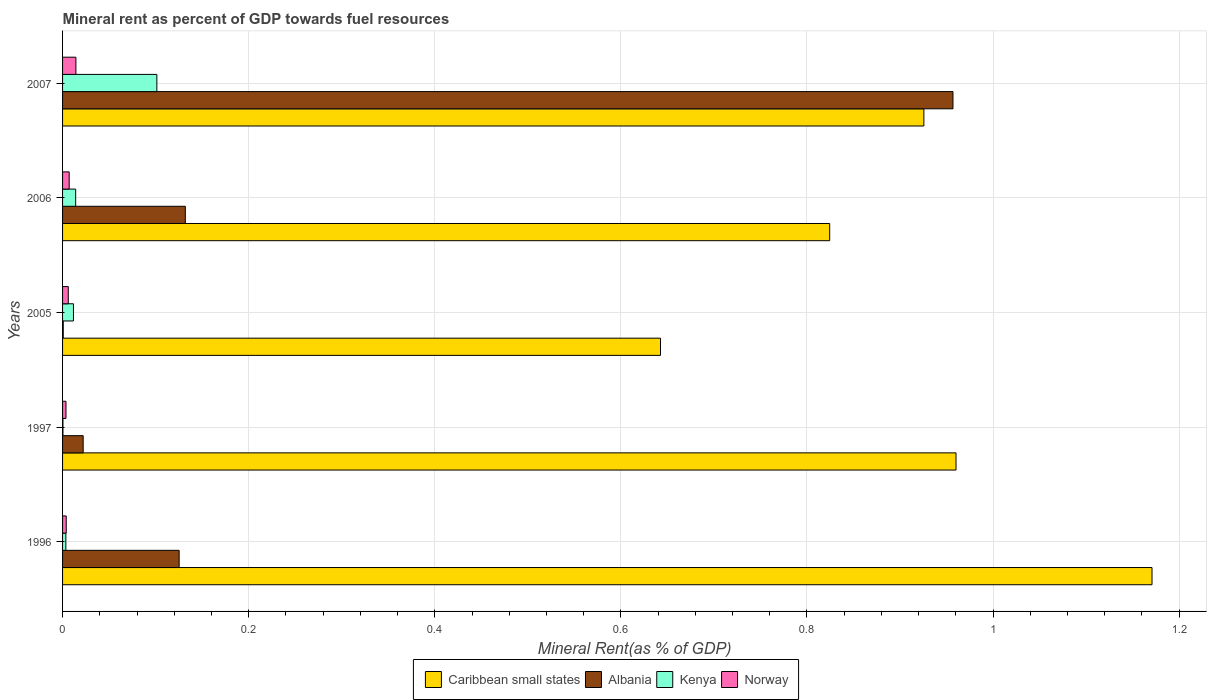How many different coloured bars are there?
Give a very brief answer. 4. How many groups of bars are there?
Offer a terse response. 5. Are the number of bars per tick equal to the number of legend labels?
Offer a very short reply. Yes. How many bars are there on the 2nd tick from the bottom?
Your response must be concise. 4. What is the label of the 1st group of bars from the top?
Give a very brief answer. 2007. What is the mineral rent in Kenya in 1997?
Your response must be concise. 0. Across all years, what is the maximum mineral rent in Albania?
Keep it short and to the point. 0.96. Across all years, what is the minimum mineral rent in Kenya?
Give a very brief answer. 0. In which year was the mineral rent in Albania minimum?
Provide a short and direct response. 2005. What is the total mineral rent in Albania in the graph?
Give a very brief answer. 1.24. What is the difference between the mineral rent in Caribbean small states in 1997 and that in 2007?
Provide a short and direct response. 0.03. What is the difference between the mineral rent in Norway in 1996 and the mineral rent in Kenya in 1997?
Make the answer very short. 0. What is the average mineral rent in Norway per year?
Offer a very short reply. 0.01. In the year 2006, what is the difference between the mineral rent in Albania and mineral rent in Kenya?
Provide a short and direct response. 0.12. In how many years, is the mineral rent in Norway greater than 0.16 %?
Provide a succinct answer. 0. What is the ratio of the mineral rent in Albania in 2006 to that in 2007?
Your answer should be compact. 0.14. Is the difference between the mineral rent in Albania in 2005 and 2006 greater than the difference between the mineral rent in Kenya in 2005 and 2006?
Your answer should be compact. No. What is the difference between the highest and the second highest mineral rent in Kenya?
Ensure brevity in your answer.  0.09. What is the difference between the highest and the lowest mineral rent in Kenya?
Give a very brief answer. 0.1. In how many years, is the mineral rent in Kenya greater than the average mineral rent in Kenya taken over all years?
Offer a very short reply. 1. What does the 2nd bar from the top in 2006 represents?
Your answer should be compact. Kenya. What does the 1st bar from the bottom in 2005 represents?
Give a very brief answer. Caribbean small states. Is it the case that in every year, the sum of the mineral rent in Norway and mineral rent in Caribbean small states is greater than the mineral rent in Kenya?
Your answer should be compact. Yes. Are all the bars in the graph horizontal?
Offer a terse response. Yes. How many years are there in the graph?
Offer a terse response. 5. What is the difference between two consecutive major ticks on the X-axis?
Your answer should be compact. 0.2. Are the values on the major ticks of X-axis written in scientific E-notation?
Offer a terse response. No. Does the graph contain grids?
Your response must be concise. Yes. Where does the legend appear in the graph?
Offer a very short reply. Bottom center. How many legend labels are there?
Provide a short and direct response. 4. How are the legend labels stacked?
Your answer should be very brief. Horizontal. What is the title of the graph?
Offer a very short reply. Mineral rent as percent of GDP towards fuel resources. Does "High income: nonOECD" appear as one of the legend labels in the graph?
Offer a very short reply. No. What is the label or title of the X-axis?
Your response must be concise. Mineral Rent(as % of GDP). What is the Mineral Rent(as % of GDP) in Caribbean small states in 1996?
Provide a short and direct response. 1.17. What is the Mineral Rent(as % of GDP) of Albania in 1996?
Your answer should be very brief. 0.13. What is the Mineral Rent(as % of GDP) in Kenya in 1996?
Your answer should be compact. 0. What is the Mineral Rent(as % of GDP) of Norway in 1996?
Provide a succinct answer. 0. What is the Mineral Rent(as % of GDP) of Caribbean small states in 1997?
Offer a very short reply. 0.96. What is the Mineral Rent(as % of GDP) in Albania in 1997?
Offer a very short reply. 0.02. What is the Mineral Rent(as % of GDP) in Kenya in 1997?
Ensure brevity in your answer.  0. What is the Mineral Rent(as % of GDP) of Norway in 1997?
Provide a short and direct response. 0. What is the Mineral Rent(as % of GDP) in Caribbean small states in 2005?
Offer a very short reply. 0.64. What is the Mineral Rent(as % of GDP) in Albania in 2005?
Your answer should be very brief. 0. What is the Mineral Rent(as % of GDP) of Kenya in 2005?
Provide a succinct answer. 0.01. What is the Mineral Rent(as % of GDP) of Norway in 2005?
Ensure brevity in your answer.  0.01. What is the Mineral Rent(as % of GDP) of Caribbean small states in 2006?
Keep it short and to the point. 0.82. What is the Mineral Rent(as % of GDP) in Albania in 2006?
Ensure brevity in your answer.  0.13. What is the Mineral Rent(as % of GDP) of Kenya in 2006?
Your response must be concise. 0.01. What is the Mineral Rent(as % of GDP) in Norway in 2006?
Give a very brief answer. 0.01. What is the Mineral Rent(as % of GDP) in Caribbean small states in 2007?
Your answer should be compact. 0.93. What is the Mineral Rent(as % of GDP) of Albania in 2007?
Provide a succinct answer. 0.96. What is the Mineral Rent(as % of GDP) of Kenya in 2007?
Keep it short and to the point. 0.1. What is the Mineral Rent(as % of GDP) of Norway in 2007?
Provide a short and direct response. 0.01. Across all years, what is the maximum Mineral Rent(as % of GDP) of Caribbean small states?
Your answer should be compact. 1.17. Across all years, what is the maximum Mineral Rent(as % of GDP) in Albania?
Keep it short and to the point. 0.96. Across all years, what is the maximum Mineral Rent(as % of GDP) of Kenya?
Offer a very short reply. 0.1. Across all years, what is the maximum Mineral Rent(as % of GDP) in Norway?
Provide a short and direct response. 0.01. Across all years, what is the minimum Mineral Rent(as % of GDP) in Caribbean small states?
Your answer should be compact. 0.64. Across all years, what is the minimum Mineral Rent(as % of GDP) in Albania?
Your answer should be very brief. 0. Across all years, what is the minimum Mineral Rent(as % of GDP) in Kenya?
Offer a terse response. 0. Across all years, what is the minimum Mineral Rent(as % of GDP) in Norway?
Your answer should be compact. 0. What is the total Mineral Rent(as % of GDP) in Caribbean small states in the graph?
Keep it short and to the point. 4.52. What is the total Mineral Rent(as % of GDP) in Albania in the graph?
Your response must be concise. 1.24. What is the total Mineral Rent(as % of GDP) in Kenya in the graph?
Give a very brief answer. 0.13. What is the total Mineral Rent(as % of GDP) of Norway in the graph?
Offer a very short reply. 0.04. What is the difference between the Mineral Rent(as % of GDP) of Caribbean small states in 1996 and that in 1997?
Keep it short and to the point. 0.21. What is the difference between the Mineral Rent(as % of GDP) in Albania in 1996 and that in 1997?
Make the answer very short. 0.1. What is the difference between the Mineral Rent(as % of GDP) in Kenya in 1996 and that in 1997?
Offer a very short reply. 0. What is the difference between the Mineral Rent(as % of GDP) in Norway in 1996 and that in 1997?
Provide a short and direct response. 0. What is the difference between the Mineral Rent(as % of GDP) of Caribbean small states in 1996 and that in 2005?
Offer a very short reply. 0.53. What is the difference between the Mineral Rent(as % of GDP) of Albania in 1996 and that in 2005?
Provide a succinct answer. 0.12. What is the difference between the Mineral Rent(as % of GDP) of Kenya in 1996 and that in 2005?
Your answer should be compact. -0.01. What is the difference between the Mineral Rent(as % of GDP) of Norway in 1996 and that in 2005?
Offer a terse response. -0. What is the difference between the Mineral Rent(as % of GDP) of Caribbean small states in 1996 and that in 2006?
Your answer should be very brief. 0.35. What is the difference between the Mineral Rent(as % of GDP) of Albania in 1996 and that in 2006?
Your answer should be compact. -0.01. What is the difference between the Mineral Rent(as % of GDP) of Kenya in 1996 and that in 2006?
Your response must be concise. -0.01. What is the difference between the Mineral Rent(as % of GDP) in Norway in 1996 and that in 2006?
Provide a short and direct response. -0. What is the difference between the Mineral Rent(as % of GDP) of Caribbean small states in 1996 and that in 2007?
Provide a short and direct response. 0.25. What is the difference between the Mineral Rent(as % of GDP) in Albania in 1996 and that in 2007?
Make the answer very short. -0.83. What is the difference between the Mineral Rent(as % of GDP) of Kenya in 1996 and that in 2007?
Offer a very short reply. -0.1. What is the difference between the Mineral Rent(as % of GDP) in Norway in 1996 and that in 2007?
Give a very brief answer. -0.01. What is the difference between the Mineral Rent(as % of GDP) of Caribbean small states in 1997 and that in 2005?
Offer a very short reply. 0.32. What is the difference between the Mineral Rent(as % of GDP) in Albania in 1997 and that in 2005?
Ensure brevity in your answer.  0.02. What is the difference between the Mineral Rent(as % of GDP) in Kenya in 1997 and that in 2005?
Offer a terse response. -0.01. What is the difference between the Mineral Rent(as % of GDP) in Norway in 1997 and that in 2005?
Offer a very short reply. -0. What is the difference between the Mineral Rent(as % of GDP) of Caribbean small states in 1997 and that in 2006?
Offer a terse response. 0.14. What is the difference between the Mineral Rent(as % of GDP) in Albania in 1997 and that in 2006?
Your answer should be very brief. -0.11. What is the difference between the Mineral Rent(as % of GDP) of Kenya in 1997 and that in 2006?
Offer a very short reply. -0.01. What is the difference between the Mineral Rent(as % of GDP) in Norway in 1997 and that in 2006?
Your answer should be very brief. -0. What is the difference between the Mineral Rent(as % of GDP) of Caribbean small states in 1997 and that in 2007?
Provide a short and direct response. 0.03. What is the difference between the Mineral Rent(as % of GDP) of Albania in 1997 and that in 2007?
Ensure brevity in your answer.  -0.93. What is the difference between the Mineral Rent(as % of GDP) of Kenya in 1997 and that in 2007?
Your answer should be very brief. -0.1. What is the difference between the Mineral Rent(as % of GDP) in Norway in 1997 and that in 2007?
Ensure brevity in your answer.  -0.01. What is the difference between the Mineral Rent(as % of GDP) of Caribbean small states in 2005 and that in 2006?
Provide a short and direct response. -0.18. What is the difference between the Mineral Rent(as % of GDP) of Albania in 2005 and that in 2006?
Make the answer very short. -0.13. What is the difference between the Mineral Rent(as % of GDP) in Kenya in 2005 and that in 2006?
Give a very brief answer. -0. What is the difference between the Mineral Rent(as % of GDP) in Norway in 2005 and that in 2006?
Your response must be concise. -0. What is the difference between the Mineral Rent(as % of GDP) in Caribbean small states in 2005 and that in 2007?
Make the answer very short. -0.28. What is the difference between the Mineral Rent(as % of GDP) of Albania in 2005 and that in 2007?
Make the answer very short. -0.96. What is the difference between the Mineral Rent(as % of GDP) in Kenya in 2005 and that in 2007?
Your answer should be compact. -0.09. What is the difference between the Mineral Rent(as % of GDP) in Norway in 2005 and that in 2007?
Keep it short and to the point. -0.01. What is the difference between the Mineral Rent(as % of GDP) in Caribbean small states in 2006 and that in 2007?
Your response must be concise. -0.1. What is the difference between the Mineral Rent(as % of GDP) in Albania in 2006 and that in 2007?
Make the answer very short. -0.82. What is the difference between the Mineral Rent(as % of GDP) in Kenya in 2006 and that in 2007?
Your response must be concise. -0.09. What is the difference between the Mineral Rent(as % of GDP) in Norway in 2006 and that in 2007?
Provide a short and direct response. -0.01. What is the difference between the Mineral Rent(as % of GDP) of Caribbean small states in 1996 and the Mineral Rent(as % of GDP) of Albania in 1997?
Your response must be concise. 1.15. What is the difference between the Mineral Rent(as % of GDP) of Caribbean small states in 1996 and the Mineral Rent(as % of GDP) of Kenya in 1997?
Your response must be concise. 1.17. What is the difference between the Mineral Rent(as % of GDP) of Caribbean small states in 1996 and the Mineral Rent(as % of GDP) of Norway in 1997?
Provide a succinct answer. 1.17. What is the difference between the Mineral Rent(as % of GDP) of Albania in 1996 and the Mineral Rent(as % of GDP) of Kenya in 1997?
Your answer should be compact. 0.12. What is the difference between the Mineral Rent(as % of GDP) in Albania in 1996 and the Mineral Rent(as % of GDP) in Norway in 1997?
Ensure brevity in your answer.  0.12. What is the difference between the Mineral Rent(as % of GDP) in Kenya in 1996 and the Mineral Rent(as % of GDP) in Norway in 1997?
Your answer should be compact. -0. What is the difference between the Mineral Rent(as % of GDP) of Caribbean small states in 1996 and the Mineral Rent(as % of GDP) of Albania in 2005?
Your answer should be compact. 1.17. What is the difference between the Mineral Rent(as % of GDP) in Caribbean small states in 1996 and the Mineral Rent(as % of GDP) in Kenya in 2005?
Your answer should be compact. 1.16. What is the difference between the Mineral Rent(as % of GDP) of Caribbean small states in 1996 and the Mineral Rent(as % of GDP) of Norway in 2005?
Provide a short and direct response. 1.16. What is the difference between the Mineral Rent(as % of GDP) of Albania in 1996 and the Mineral Rent(as % of GDP) of Kenya in 2005?
Your answer should be very brief. 0.11. What is the difference between the Mineral Rent(as % of GDP) of Albania in 1996 and the Mineral Rent(as % of GDP) of Norway in 2005?
Keep it short and to the point. 0.12. What is the difference between the Mineral Rent(as % of GDP) of Kenya in 1996 and the Mineral Rent(as % of GDP) of Norway in 2005?
Your answer should be very brief. -0. What is the difference between the Mineral Rent(as % of GDP) of Caribbean small states in 1996 and the Mineral Rent(as % of GDP) of Albania in 2006?
Make the answer very short. 1.04. What is the difference between the Mineral Rent(as % of GDP) in Caribbean small states in 1996 and the Mineral Rent(as % of GDP) in Kenya in 2006?
Offer a terse response. 1.16. What is the difference between the Mineral Rent(as % of GDP) in Caribbean small states in 1996 and the Mineral Rent(as % of GDP) in Norway in 2006?
Provide a succinct answer. 1.16. What is the difference between the Mineral Rent(as % of GDP) in Albania in 1996 and the Mineral Rent(as % of GDP) in Kenya in 2006?
Provide a succinct answer. 0.11. What is the difference between the Mineral Rent(as % of GDP) in Albania in 1996 and the Mineral Rent(as % of GDP) in Norway in 2006?
Provide a succinct answer. 0.12. What is the difference between the Mineral Rent(as % of GDP) of Kenya in 1996 and the Mineral Rent(as % of GDP) of Norway in 2006?
Provide a short and direct response. -0. What is the difference between the Mineral Rent(as % of GDP) of Caribbean small states in 1996 and the Mineral Rent(as % of GDP) of Albania in 2007?
Provide a succinct answer. 0.21. What is the difference between the Mineral Rent(as % of GDP) in Caribbean small states in 1996 and the Mineral Rent(as % of GDP) in Kenya in 2007?
Offer a very short reply. 1.07. What is the difference between the Mineral Rent(as % of GDP) of Caribbean small states in 1996 and the Mineral Rent(as % of GDP) of Norway in 2007?
Your answer should be very brief. 1.16. What is the difference between the Mineral Rent(as % of GDP) in Albania in 1996 and the Mineral Rent(as % of GDP) in Kenya in 2007?
Keep it short and to the point. 0.02. What is the difference between the Mineral Rent(as % of GDP) in Albania in 1996 and the Mineral Rent(as % of GDP) in Norway in 2007?
Provide a short and direct response. 0.11. What is the difference between the Mineral Rent(as % of GDP) in Kenya in 1996 and the Mineral Rent(as % of GDP) in Norway in 2007?
Make the answer very short. -0.01. What is the difference between the Mineral Rent(as % of GDP) of Caribbean small states in 1997 and the Mineral Rent(as % of GDP) of Albania in 2005?
Your answer should be very brief. 0.96. What is the difference between the Mineral Rent(as % of GDP) in Caribbean small states in 1997 and the Mineral Rent(as % of GDP) in Kenya in 2005?
Your response must be concise. 0.95. What is the difference between the Mineral Rent(as % of GDP) in Caribbean small states in 1997 and the Mineral Rent(as % of GDP) in Norway in 2005?
Provide a succinct answer. 0.95. What is the difference between the Mineral Rent(as % of GDP) in Albania in 1997 and the Mineral Rent(as % of GDP) in Kenya in 2005?
Your answer should be compact. 0.01. What is the difference between the Mineral Rent(as % of GDP) of Albania in 1997 and the Mineral Rent(as % of GDP) of Norway in 2005?
Ensure brevity in your answer.  0.02. What is the difference between the Mineral Rent(as % of GDP) in Kenya in 1997 and the Mineral Rent(as % of GDP) in Norway in 2005?
Keep it short and to the point. -0.01. What is the difference between the Mineral Rent(as % of GDP) of Caribbean small states in 1997 and the Mineral Rent(as % of GDP) of Albania in 2006?
Offer a very short reply. 0.83. What is the difference between the Mineral Rent(as % of GDP) in Caribbean small states in 1997 and the Mineral Rent(as % of GDP) in Kenya in 2006?
Your response must be concise. 0.95. What is the difference between the Mineral Rent(as % of GDP) in Caribbean small states in 1997 and the Mineral Rent(as % of GDP) in Norway in 2006?
Your answer should be very brief. 0.95. What is the difference between the Mineral Rent(as % of GDP) of Albania in 1997 and the Mineral Rent(as % of GDP) of Kenya in 2006?
Offer a very short reply. 0.01. What is the difference between the Mineral Rent(as % of GDP) in Albania in 1997 and the Mineral Rent(as % of GDP) in Norway in 2006?
Give a very brief answer. 0.01. What is the difference between the Mineral Rent(as % of GDP) in Kenya in 1997 and the Mineral Rent(as % of GDP) in Norway in 2006?
Provide a short and direct response. -0.01. What is the difference between the Mineral Rent(as % of GDP) of Caribbean small states in 1997 and the Mineral Rent(as % of GDP) of Albania in 2007?
Your answer should be very brief. 0. What is the difference between the Mineral Rent(as % of GDP) of Caribbean small states in 1997 and the Mineral Rent(as % of GDP) of Kenya in 2007?
Provide a succinct answer. 0.86. What is the difference between the Mineral Rent(as % of GDP) of Caribbean small states in 1997 and the Mineral Rent(as % of GDP) of Norway in 2007?
Your response must be concise. 0.95. What is the difference between the Mineral Rent(as % of GDP) in Albania in 1997 and the Mineral Rent(as % of GDP) in Kenya in 2007?
Offer a terse response. -0.08. What is the difference between the Mineral Rent(as % of GDP) in Albania in 1997 and the Mineral Rent(as % of GDP) in Norway in 2007?
Your answer should be compact. 0.01. What is the difference between the Mineral Rent(as % of GDP) of Kenya in 1997 and the Mineral Rent(as % of GDP) of Norway in 2007?
Your response must be concise. -0.01. What is the difference between the Mineral Rent(as % of GDP) in Caribbean small states in 2005 and the Mineral Rent(as % of GDP) in Albania in 2006?
Ensure brevity in your answer.  0.51. What is the difference between the Mineral Rent(as % of GDP) in Caribbean small states in 2005 and the Mineral Rent(as % of GDP) in Kenya in 2006?
Provide a short and direct response. 0.63. What is the difference between the Mineral Rent(as % of GDP) in Caribbean small states in 2005 and the Mineral Rent(as % of GDP) in Norway in 2006?
Keep it short and to the point. 0.64. What is the difference between the Mineral Rent(as % of GDP) in Albania in 2005 and the Mineral Rent(as % of GDP) in Kenya in 2006?
Keep it short and to the point. -0.01. What is the difference between the Mineral Rent(as % of GDP) of Albania in 2005 and the Mineral Rent(as % of GDP) of Norway in 2006?
Your answer should be very brief. -0.01. What is the difference between the Mineral Rent(as % of GDP) of Kenya in 2005 and the Mineral Rent(as % of GDP) of Norway in 2006?
Make the answer very short. 0. What is the difference between the Mineral Rent(as % of GDP) in Caribbean small states in 2005 and the Mineral Rent(as % of GDP) in Albania in 2007?
Your answer should be very brief. -0.31. What is the difference between the Mineral Rent(as % of GDP) of Caribbean small states in 2005 and the Mineral Rent(as % of GDP) of Kenya in 2007?
Keep it short and to the point. 0.54. What is the difference between the Mineral Rent(as % of GDP) of Caribbean small states in 2005 and the Mineral Rent(as % of GDP) of Norway in 2007?
Your answer should be compact. 0.63. What is the difference between the Mineral Rent(as % of GDP) in Albania in 2005 and the Mineral Rent(as % of GDP) in Kenya in 2007?
Your answer should be very brief. -0.1. What is the difference between the Mineral Rent(as % of GDP) in Albania in 2005 and the Mineral Rent(as % of GDP) in Norway in 2007?
Offer a very short reply. -0.01. What is the difference between the Mineral Rent(as % of GDP) in Kenya in 2005 and the Mineral Rent(as % of GDP) in Norway in 2007?
Give a very brief answer. -0. What is the difference between the Mineral Rent(as % of GDP) of Caribbean small states in 2006 and the Mineral Rent(as % of GDP) of Albania in 2007?
Offer a very short reply. -0.13. What is the difference between the Mineral Rent(as % of GDP) in Caribbean small states in 2006 and the Mineral Rent(as % of GDP) in Kenya in 2007?
Provide a short and direct response. 0.72. What is the difference between the Mineral Rent(as % of GDP) of Caribbean small states in 2006 and the Mineral Rent(as % of GDP) of Norway in 2007?
Your answer should be very brief. 0.81. What is the difference between the Mineral Rent(as % of GDP) in Albania in 2006 and the Mineral Rent(as % of GDP) in Kenya in 2007?
Your answer should be compact. 0.03. What is the difference between the Mineral Rent(as % of GDP) in Albania in 2006 and the Mineral Rent(as % of GDP) in Norway in 2007?
Give a very brief answer. 0.12. What is the difference between the Mineral Rent(as % of GDP) in Kenya in 2006 and the Mineral Rent(as % of GDP) in Norway in 2007?
Your response must be concise. -0. What is the average Mineral Rent(as % of GDP) in Caribbean small states per year?
Make the answer very short. 0.9. What is the average Mineral Rent(as % of GDP) of Albania per year?
Keep it short and to the point. 0.25. What is the average Mineral Rent(as % of GDP) of Kenya per year?
Give a very brief answer. 0.03. What is the average Mineral Rent(as % of GDP) of Norway per year?
Give a very brief answer. 0.01. In the year 1996, what is the difference between the Mineral Rent(as % of GDP) of Caribbean small states and Mineral Rent(as % of GDP) of Albania?
Provide a short and direct response. 1.05. In the year 1996, what is the difference between the Mineral Rent(as % of GDP) of Caribbean small states and Mineral Rent(as % of GDP) of Kenya?
Your response must be concise. 1.17. In the year 1996, what is the difference between the Mineral Rent(as % of GDP) in Caribbean small states and Mineral Rent(as % of GDP) in Norway?
Offer a very short reply. 1.17. In the year 1996, what is the difference between the Mineral Rent(as % of GDP) of Albania and Mineral Rent(as % of GDP) of Kenya?
Give a very brief answer. 0.12. In the year 1996, what is the difference between the Mineral Rent(as % of GDP) of Albania and Mineral Rent(as % of GDP) of Norway?
Make the answer very short. 0.12. In the year 1996, what is the difference between the Mineral Rent(as % of GDP) in Kenya and Mineral Rent(as % of GDP) in Norway?
Provide a short and direct response. -0. In the year 1997, what is the difference between the Mineral Rent(as % of GDP) of Caribbean small states and Mineral Rent(as % of GDP) of Albania?
Provide a short and direct response. 0.94. In the year 1997, what is the difference between the Mineral Rent(as % of GDP) of Caribbean small states and Mineral Rent(as % of GDP) of Kenya?
Your answer should be very brief. 0.96. In the year 1997, what is the difference between the Mineral Rent(as % of GDP) of Caribbean small states and Mineral Rent(as % of GDP) of Norway?
Keep it short and to the point. 0.96. In the year 1997, what is the difference between the Mineral Rent(as % of GDP) in Albania and Mineral Rent(as % of GDP) in Kenya?
Ensure brevity in your answer.  0.02. In the year 1997, what is the difference between the Mineral Rent(as % of GDP) in Albania and Mineral Rent(as % of GDP) in Norway?
Provide a succinct answer. 0.02. In the year 1997, what is the difference between the Mineral Rent(as % of GDP) in Kenya and Mineral Rent(as % of GDP) in Norway?
Your answer should be compact. -0. In the year 2005, what is the difference between the Mineral Rent(as % of GDP) of Caribbean small states and Mineral Rent(as % of GDP) of Albania?
Your response must be concise. 0.64. In the year 2005, what is the difference between the Mineral Rent(as % of GDP) in Caribbean small states and Mineral Rent(as % of GDP) in Kenya?
Provide a short and direct response. 0.63. In the year 2005, what is the difference between the Mineral Rent(as % of GDP) in Caribbean small states and Mineral Rent(as % of GDP) in Norway?
Offer a terse response. 0.64. In the year 2005, what is the difference between the Mineral Rent(as % of GDP) in Albania and Mineral Rent(as % of GDP) in Kenya?
Give a very brief answer. -0.01. In the year 2005, what is the difference between the Mineral Rent(as % of GDP) of Albania and Mineral Rent(as % of GDP) of Norway?
Your response must be concise. -0.01. In the year 2005, what is the difference between the Mineral Rent(as % of GDP) of Kenya and Mineral Rent(as % of GDP) of Norway?
Ensure brevity in your answer.  0.01. In the year 2006, what is the difference between the Mineral Rent(as % of GDP) in Caribbean small states and Mineral Rent(as % of GDP) in Albania?
Keep it short and to the point. 0.69. In the year 2006, what is the difference between the Mineral Rent(as % of GDP) in Caribbean small states and Mineral Rent(as % of GDP) in Kenya?
Give a very brief answer. 0.81. In the year 2006, what is the difference between the Mineral Rent(as % of GDP) of Caribbean small states and Mineral Rent(as % of GDP) of Norway?
Offer a terse response. 0.82. In the year 2006, what is the difference between the Mineral Rent(as % of GDP) in Albania and Mineral Rent(as % of GDP) in Kenya?
Offer a terse response. 0.12. In the year 2006, what is the difference between the Mineral Rent(as % of GDP) in Albania and Mineral Rent(as % of GDP) in Norway?
Your response must be concise. 0.12. In the year 2006, what is the difference between the Mineral Rent(as % of GDP) in Kenya and Mineral Rent(as % of GDP) in Norway?
Give a very brief answer. 0.01. In the year 2007, what is the difference between the Mineral Rent(as % of GDP) in Caribbean small states and Mineral Rent(as % of GDP) in Albania?
Keep it short and to the point. -0.03. In the year 2007, what is the difference between the Mineral Rent(as % of GDP) in Caribbean small states and Mineral Rent(as % of GDP) in Kenya?
Your answer should be compact. 0.82. In the year 2007, what is the difference between the Mineral Rent(as % of GDP) of Caribbean small states and Mineral Rent(as % of GDP) of Norway?
Offer a very short reply. 0.91. In the year 2007, what is the difference between the Mineral Rent(as % of GDP) in Albania and Mineral Rent(as % of GDP) in Kenya?
Give a very brief answer. 0.86. In the year 2007, what is the difference between the Mineral Rent(as % of GDP) in Albania and Mineral Rent(as % of GDP) in Norway?
Provide a succinct answer. 0.94. In the year 2007, what is the difference between the Mineral Rent(as % of GDP) of Kenya and Mineral Rent(as % of GDP) of Norway?
Offer a terse response. 0.09. What is the ratio of the Mineral Rent(as % of GDP) of Caribbean small states in 1996 to that in 1997?
Offer a very short reply. 1.22. What is the ratio of the Mineral Rent(as % of GDP) in Albania in 1996 to that in 1997?
Provide a short and direct response. 5.66. What is the ratio of the Mineral Rent(as % of GDP) in Kenya in 1996 to that in 1997?
Your answer should be very brief. 8.69. What is the ratio of the Mineral Rent(as % of GDP) of Norway in 1996 to that in 1997?
Keep it short and to the point. 1.07. What is the ratio of the Mineral Rent(as % of GDP) in Caribbean small states in 1996 to that in 2005?
Provide a succinct answer. 1.82. What is the ratio of the Mineral Rent(as % of GDP) of Albania in 1996 to that in 2005?
Your answer should be compact. 176.01. What is the ratio of the Mineral Rent(as % of GDP) of Kenya in 1996 to that in 2005?
Offer a very short reply. 0.3. What is the ratio of the Mineral Rent(as % of GDP) of Norway in 1996 to that in 2005?
Your answer should be compact. 0.64. What is the ratio of the Mineral Rent(as % of GDP) of Caribbean small states in 1996 to that in 2006?
Make the answer very short. 1.42. What is the ratio of the Mineral Rent(as % of GDP) in Albania in 1996 to that in 2006?
Offer a very short reply. 0.95. What is the ratio of the Mineral Rent(as % of GDP) of Kenya in 1996 to that in 2006?
Your response must be concise. 0.25. What is the ratio of the Mineral Rent(as % of GDP) in Norway in 1996 to that in 2006?
Ensure brevity in your answer.  0.55. What is the ratio of the Mineral Rent(as % of GDP) in Caribbean small states in 1996 to that in 2007?
Provide a short and direct response. 1.26. What is the ratio of the Mineral Rent(as % of GDP) of Albania in 1996 to that in 2007?
Give a very brief answer. 0.13. What is the ratio of the Mineral Rent(as % of GDP) of Kenya in 1996 to that in 2007?
Ensure brevity in your answer.  0.03. What is the ratio of the Mineral Rent(as % of GDP) of Norway in 1996 to that in 2007?
Offer a terse response. 0.27. What is the ratio of the Mineral Rent(as % of GDP) of Caribbean small states in 1997 to that in 2005?
Your response must be concise. 1.49. What is the ratio of the Mineral Rent(as % of GDP) of Albania in 1997 to that in 2005?
Give a very brief answer. 31.11. What is the ratio of the Mineral Rent(as % of GDP) in Kenya in 1997 to that in 2005?
Offer a very short reply. 0.03. What is the ratio of the Mineral Rent(as % of GDP) in Norway in 1997 to that in 2005?
Your response must be concise. 0.6. What is the ratio of the Mineral Rent(as % of GDP) in Caribbean small states in 1997 to that in 2006?
Provide a short and direct response. 1.16. What is the ratio of the Mineral Rent(as % of GDP) in Albania in 1997 to that in 2006?
Give a very brief answer. 0.17. What is the ratio of the Mineral Rent(as % of GDP) of Kenya in 1997 to that in 2006?
Offer a terse response. 0.03. What is the ratio of the Mineral Rent(as % of GDP) of Norway in 1997 to that in 2006?
Give a very brief answer. 0.52. What is the ratio of the Mineral Rent(as % of GDP) in Caribbean small states in 1997 to that in 2007?
Give a very brief answer. 1.04. What is the ratio of the Mineral Rent(as % of GDP) in Albania in 1997 to that in 2007?
Keep it short and to the point. 0.02. What is the ratio of the Mineral Rent(as % of GDP) of Kenya in 1997 to that in 2007?
Your answer should be very brief. 0. What is the ratio of the Mineral Rent(as % of GDP) of Norway in 1997 to that in 2007?
Ensure brevity in your answer.  0.26. What is the ratio of the Mineral Rent(as % of GDP) of Caribbean small states in 2005 to that in 2006?
Your answer should be compact. 0.78. What is the ratio of the Mineral Rent(as % of GDP) of Albania in 2005 to that in 2006?
Provide a short and direct response. 0.01. What is the ratio of the Mineral Rent(as % of GDP) in Kenya in 2005 to that in 2006?
Keep it short and to the point. 0.83. What is the ratio of the Mineral Rent(as % of GDP) of Norway in 2005 to that in 2006?
Keep it short and to the point. 0.86. What is the ratio of the Mineral Rent(as % of GDP) in Caribbean small states in 2005 to that in 2007?
Offer a very short reply. 0.69. What is the ratio of the Mineral Rent(as % of GDP) of Albania in 2005 to that in 2007?
Your answer should be compact. 0. What is the ratio of the Mineral Rent(as % of GDP) of Kenya in 2005 to that in 2007?
Make the answer very short. 0.12. What is the ratio of the Mineral Rent(as % of GDP) in Norway in 2005 to that in 2007?
Ensure brevity in your answer.  0.43. What is the ratio of the Mineral Rent(as % of GDP) in Caribbean small states in 2006 to that in 2007?
Give a very brief answer. 0.89. What is the ratio of the Mineral Rent(as % of GDP) of Albania in 2006 to that in 2007?
Ensure brevity in your answer.  0.14. What is the ratio of the Mineral Rent(as % of GDP) in Kenya in 2006 to that in 2007?
Ensure brevity in your answer.  0.14. What is the ratio of the Mineral Rent(as % of GDP) in Norway in 2006 to that in 2007?
Provide a short and direct response. 0.5. What is the difference between the highest and the second highest Mineral Rent(as % of GDP) of Caribbean small states?
Your response must be concise. 0.21. What is the difference between the highest and the second highest Mineral Rent(as % of GDP) of Albania?
Provide a short and direct response. 0.82. What is the difference between the highest and the second highest Mineral Rent(as % of GDP) in Kenya?
Your answer should be compact. 0.09. What is the difference between the highest and the second highest Mineral Rent(as % of GDP) of Norway?
Make the answer very short. 0.01. What is the difference between the highest and the lowest Mineral Rent(as % of GDP) in Caribbean small states?
Keep it short and to the point. 0.53. What is the difference between the highest and the lowest Mineral Rent(as % of GDP) of Albania?
Offer a terse response. 0.96. What is the difference between the highest and the lowest Mineral Rent(as % of GDP) of Kenya?
Your answer should be very brief. 0.1. What is the difference between the highest and the lowest Mineral Rent(as % of GDP) of Norway?
Offer a very short reply. 0.01. 